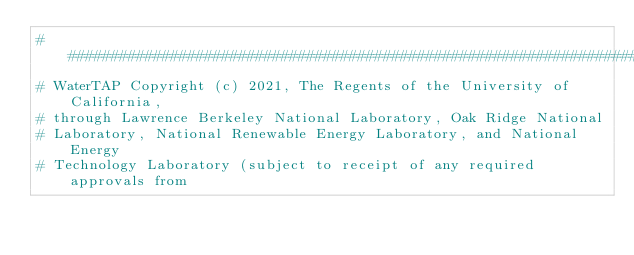<code> <loc_0><loc_0><loc_500><loc_500><_Python_>###############################################################################
# WaterTAP Copyright (c) 2021, The Regents of the University of California,
# through Lawrence Berkeley National Laboratory, Oak Ridge National
# Laboratory, National Renewable Energy Laboratory, and National Energy
# Technology Laboratory (subject to receipt of any required approvals from</code> 